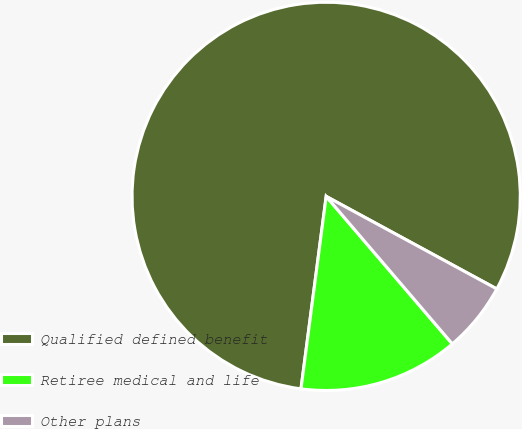Convert chart to OTSL. <chart><loc_0><loc_0><loc_500><loc_500><pie_chart><fcel>Qualified defined benefit<fcel>Retiree medical and life<fcel>Other plans<nl><fcel>80.83%<fcel>13.33%<fcel>5.83%<nl></chart> 